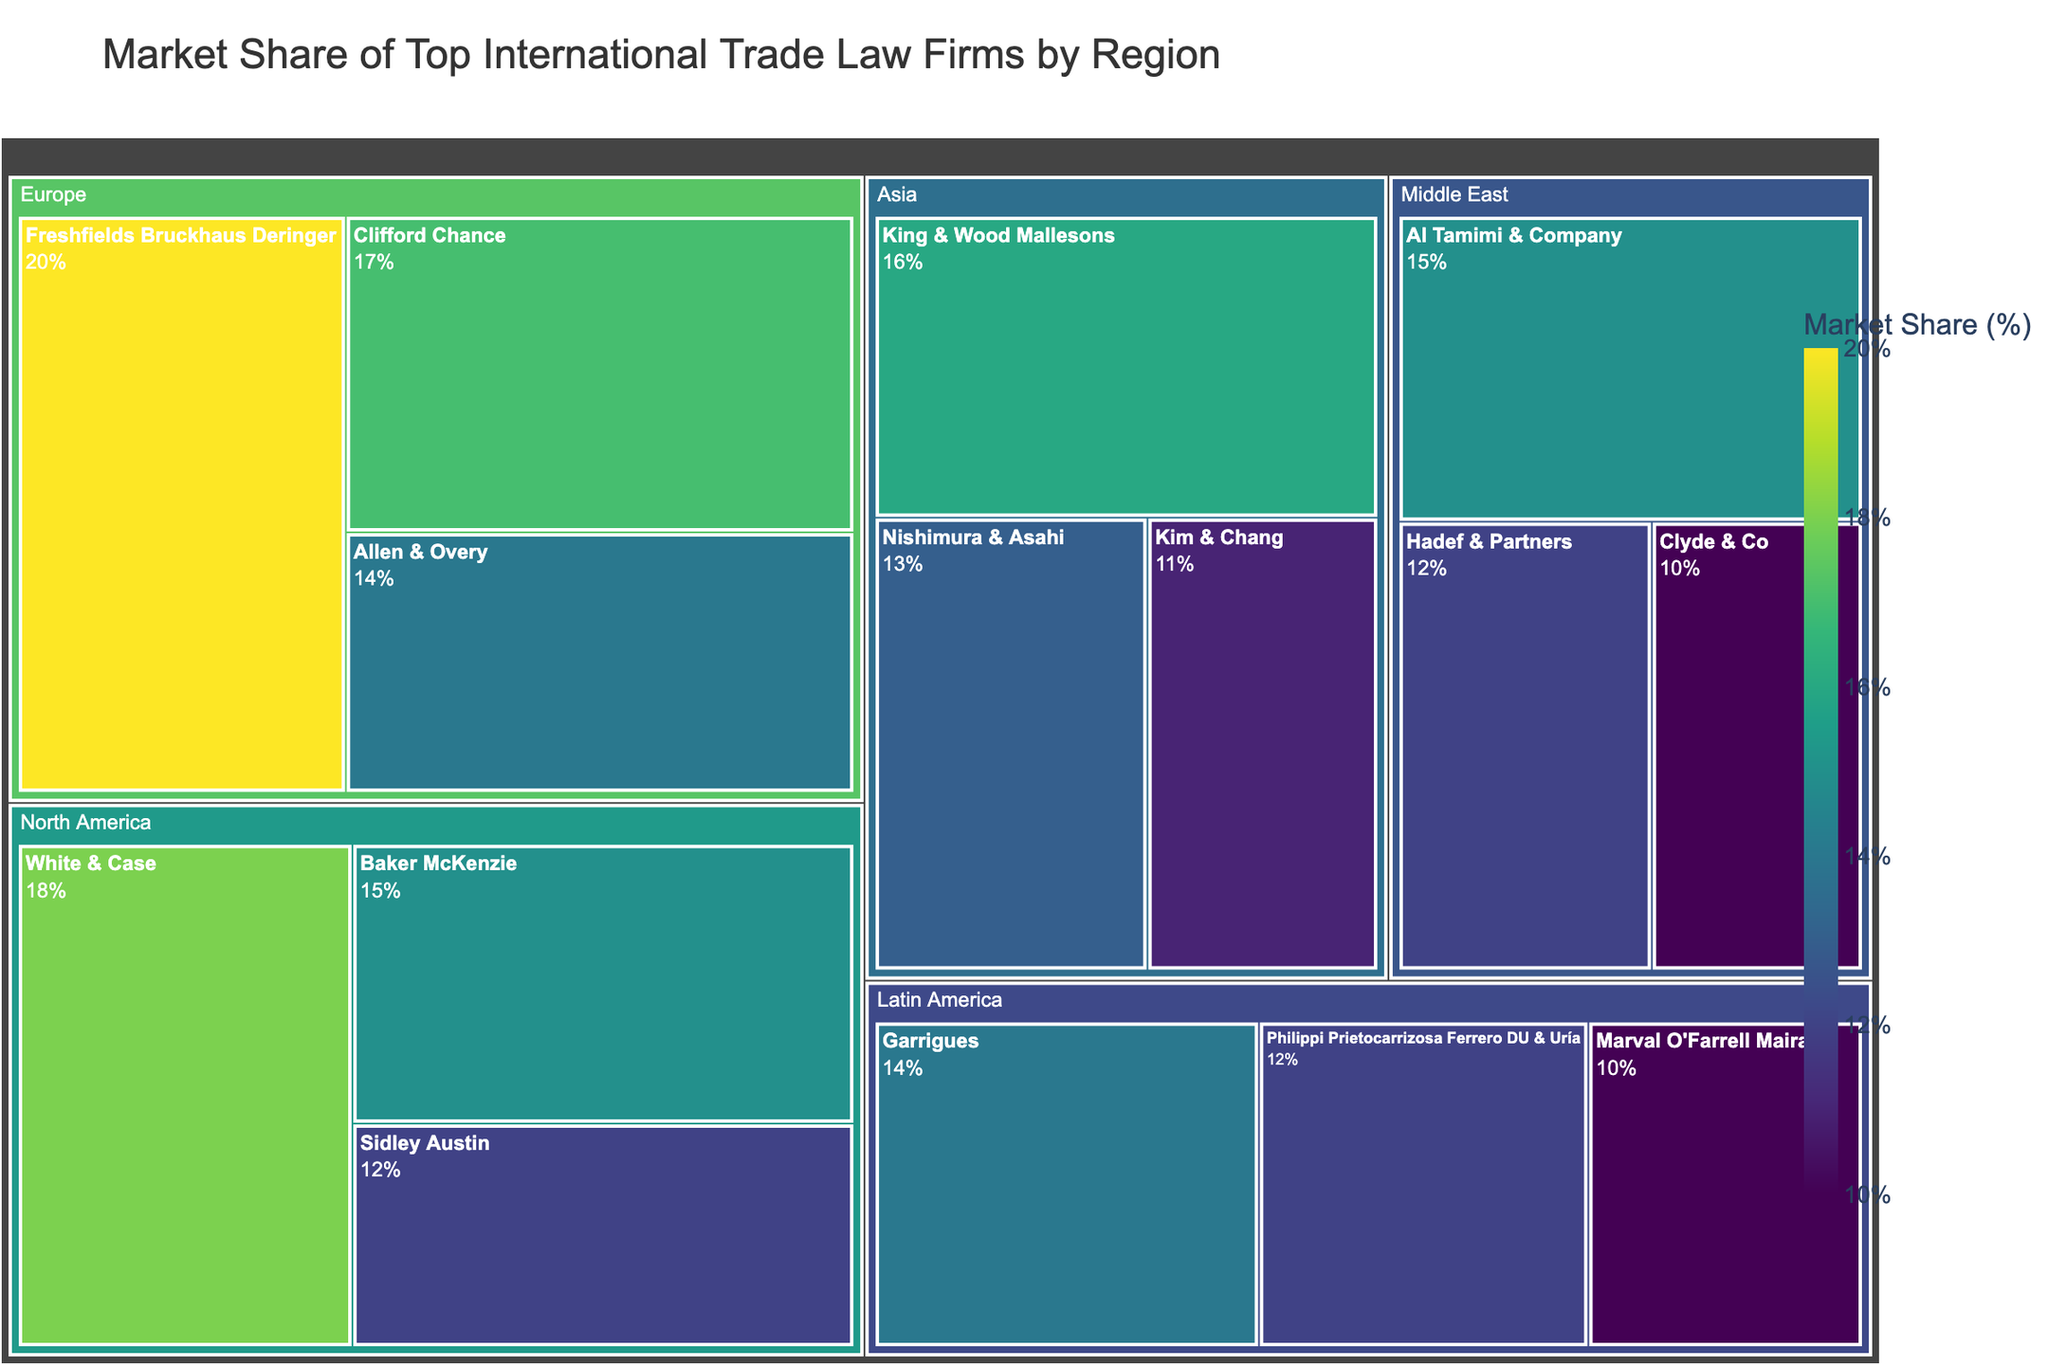What's the title of the figure? The title of the figure is typically displayed at the top of the chart. In this case, it should be specified in the title attribute of the plot.
Answer: Market Share of Top International Trade Law Firms by Region Which region has the largest market share for a single firm? To determine this, we need to look for the firm with the highest market share within each region and compare these values. The firm with the largest market share in Europe, Freshfields Bruckhaus Deringer, at 20%, is the highest.
Answer: Europe Which firm has the largest market share in North America? By looking at the firms listed under the North America region, we can identify White & Case as having an 18% market share, the highest in North America.
Answer: White & Case How many firms are displayed for the Asia region? The number of firms represented in the Treemap for the Asia region can be counted. There are three firms listed: King & Wood Mallesons, Nishimura & Asahi, and Kim & Chang.
Answer: 3 Which firm has the smallest market share in Latin America? By observing the firms within the Latin America region, Marval O'Farrell Mairal has the smallest market share at 10%.
Answer: Marval O'Farrell Mairal What is the total market share percentage for Europe? To find this, we sum the market shares of all firms in Europe: 20% (Freshfields Bruckhaus Deringer) + 17% (Clifford Chance) + 14% (Allen & Overy) = 51%.
Answer: 51% Is any firm in the Middle East region's market share higher than 15%? By reviewing the firms in the Middle East region, the highest market share is 15%, held by Al Tamimi & Company, but no firm has a market share higher than 15%.
Answer: No Which region has the most even distribution of market shares among its firms? To determine this, we compare how close the market shares are within each region. The Middle East region has firms with market shares of 15%, 12%, and 10%, a relatively even distribution compared to other regions.
Answer: Middle East How does the market share of Baker McKenzie compare to that of King & Wood Mallesons? Baker McKenzie's market share (15%) in North America is compared with King & Wood Mallesons' market share (16%) in Asia. Thus, King & Wood Mallesons has a 1% higher market share than Baker McKenzie.
Answer: King & Wood Mallesons has 1% more Which firm has the smallest market share among all regions combined? By identifying the smallest market shares in the combined dataset of all regions, Marval O'Farrell Mairal in Latin America and Clyde & Co. in the Middle East, each with 10%, are the smallest.
Answer: Marval O'Farrell Mairal and Clyde & Co 